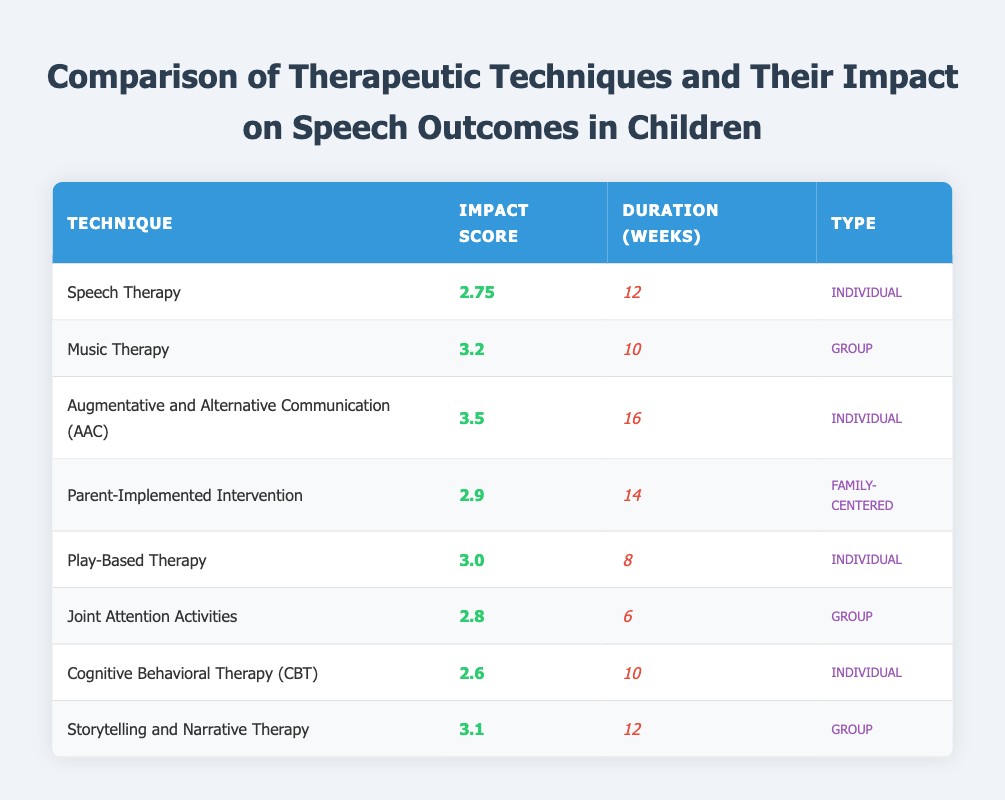What is the impact score of Music Therapy? The impact score of Music Therapy can be directly retrieved from the table. It is listed under the column for impact scores.
Answer: 3.2 How long does Play-Based Therapy last? The duration of Play-Based Therapy is provided in the corresponding row of the table, specifically under the Duration (Weeks) column.
Answer: 8 Is the impact score of Cognitive Behavioral Therapy higher than that of Joint Attention Activities? The impact score for Cognitive Behavioral Therapy is 2.6, whereas Joint Attention Activities has an impact score of 2.8. Since 2.6 is not greater than 2.8, the answer is no.
Answer: No What is the average impact score of the Individual type therapies? There are four individual therapies: Speech Therapy (2.75), AAC (3.5), Play-Based Therapy (3.0), and CBT (2.6). Adding these scores gives 2.75 + 3.5 + 3.0 + 2.6 = 12.85. Dividing by 4 gives an average of 12.85 / 4 = 3.2125.
Answer: 3.21 Which therapy has the longest duration among the techniques listed? Looking through the Duration (Weeks) column, we see that AAC has the highest duration of 16 weeks, which is longer than all other techniques listed.
Answer: Augmentative and Alternative Communication (AAC) What is the total impact score of all group therapies? The group therapies listed are Music Therapy (3.2), Joint Attention Activities (2.8), and Storytelling and Narrative Therapy (3.1). Summing these scores gives 3.2 + 2.8 + 3.1 = 9.1.
Answer: 9.1 Is Play-Based Therapy considered a family-centered intervention? Play-Based Therapy is categorized as "Individual" in the Type column, which indicates it is not a family-centered intervention.
Answer: No 